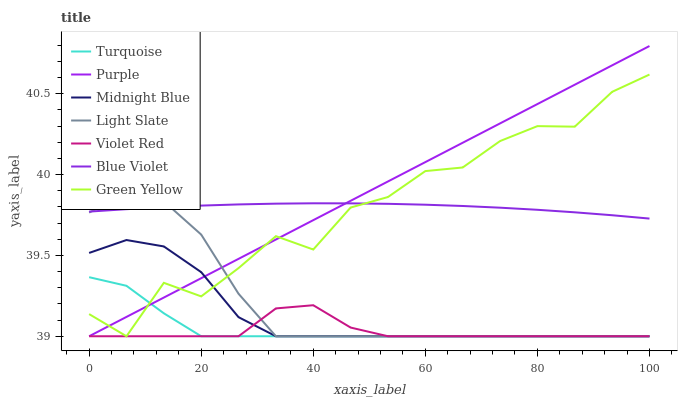Does Violet Red have the minimum area under the curve?
Answer yes or no. Yes. Does Purple have the maximum area under the curve?
Answer yes or no. Yes. Does Midnight Blue have the minimum area under the curve?
Answer yes or no. No. Does Midnight Blue have the maximum area under the curve?
Answer yes or no. No. Is Purple the smoothest?
Answer yes or no. Yes. Is Green Yellow the roughest?
Answer yes or no. Yes. Is Midnight Blue the smoothest?
Answer yes or no. No. Is Midnight Blue the roughest?
Answer yes or no. No. Does Turquoise have the lowest value?
Answer yes or no. Yes. Does Green Yellow have the lowest value?
Answer yes or no. No. Does Purple have the highest value?
Answer yes or no. Yes. Does Midnight Blue have the highest value?
Answer yes or no. No. Is Turquoise less than Blue Violet?
Answer yes or no. Yes. Is Blue Violet greater than Midnight Blue?
Answer yes or no. Yes. Does Turquoise intersect Green Yellow?
Answer yes or no. Yes. Is Turquoise less than Green Yellow?
Answer yes or no. No. Is Turquoise greater than Green Yellow?
Answer yes or no. No. Does Turquoise intersect Blue Violet?
Answer yes or no. No. 